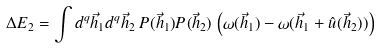Convert formula to latex. <formula><loc_0><loc_0><loc_500><loc_500>\Delta E _ { 2 } = \int d ^ { q } \vec { h } _ { 1 } d ^ { q } \vec { h } _ { 2 } \, P ( \vec { h } _ { 1 } ) P ( \vec { h } _ { 2 } ) \, \left ( \omega ( \vec { h } _ { 1 } ) - \omega ( \vec { h } _ { 1 } + \hat { u } ( \vec { h } _ { 2 } ) ) \right )</formula> 